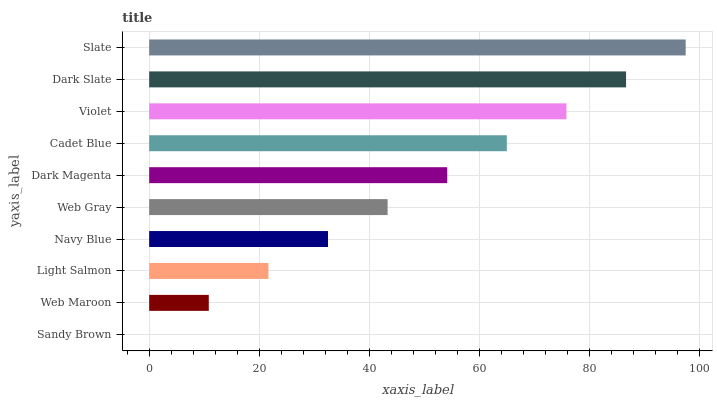Is Sandy Brown the minimum?
Answer yes or no. Yes. Is Slate the maximum?
Answer yes or no. Yes. Is Web Maroon the minimum?
Answer yes or no. No. Is Web Maroon the maximum?
Answer yes or no. No. Is Web Maroon greater than Sandy Brown?
Answer yes or no. Yes. Is Sandy Brown less than Web Maroon?
Answer yes or no. Yes. Is Sandy Brown greater than Web Maroon?
Answer yes or no. No. Is Web Maroon less than Sandy Brown?
Answer yes or no. No. Is Dark Magenta the high median?
Answer yes or no. Yes. Is Web Gray the low median?
Answer yes or no. Yes. Is Web Gray the high median?
Answer yes or no. No. Is Slate the low median?
Answer yes or no. No. 